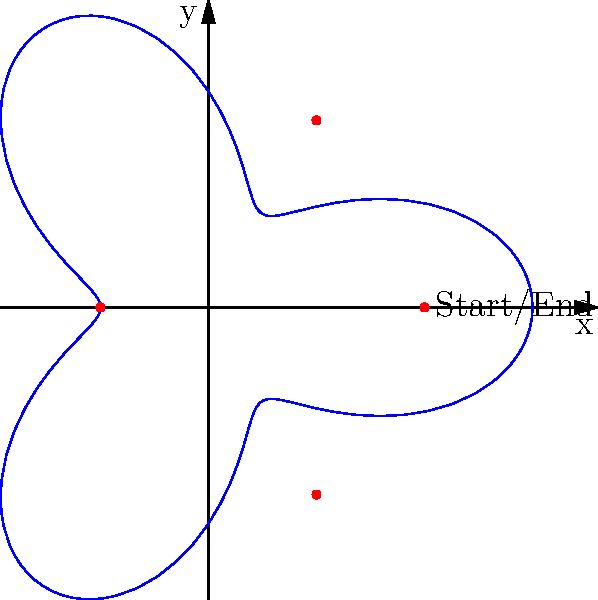A women's rights march is planned in Athens, Ohio, following a path described by the polar equation $r = 2 + \cos(3\theta)$. The march starts and ends at the point (2,0). How many times does the march pass through the origin, and what are the polar coordinates of the other three vertices of the path? To solve this problem, let's follow these steps:

1) The equation $r = 2 + \cos(3\theta)$ represents a three-leaved rose curve.

2) To find how many times the march passes through the origin, we need to solve:
   $2 + \cos(3\theta) = 0$
   $\cos(3\theta) = -2$
   This equation has no solution because cosine is always between -1 and 1. Therefore, the march never passes through the origin.

3) To find the vertices, we need to find the maximum and minimum values of r:
   Maximum: When $\cos(3\theta) = 1$, $r_{max} = 2 + 1 = 3$
   Minimum: When $\cos(3\theta) = -1$, $r_{min} = 2 - 1 = 1$

4) The maximum occurs at $\theta = 0, \frac{2\pi}{3}, \frac{4\pi}{3}$, giving the points:
   $(3,0)$, $(-\frac{3}{2},\frac{3\sqrt{3}}{2})$, $(-\frac{3}{2},-\frac{3\sqrt{3}}{2})$

5) The minimum occurs at $\theta = \frac{\pi}{3}, \pi, \frac{5\pi}{3}$, giving the points:
   $(1,0)$, $(-1,0)$, $(1,\sqrt{3})$, $(1,-\sqrt{3})$

6) The start/end point (2,0) is not a vertex. The other three vertices are the points where $r = 1$:
   $(-1,0)$, $(1,\sqrt{3})$, $(1,-\sqrt{3})$

7) Converting to polar coordinates:
   $(-1,0)$ is $(1,\pi)$
   $(1,\sqrt{3})$ is $(2,\frac{\pi}{3})$
   $(1,-\sqrt{3})$ is $(2,\frac{5\pi}{3})$
Answer: 0 times; $(1,\pi)$, $(2,\frac{\pi}{3})$, $(2,\frac{5\pi}{3})$ 